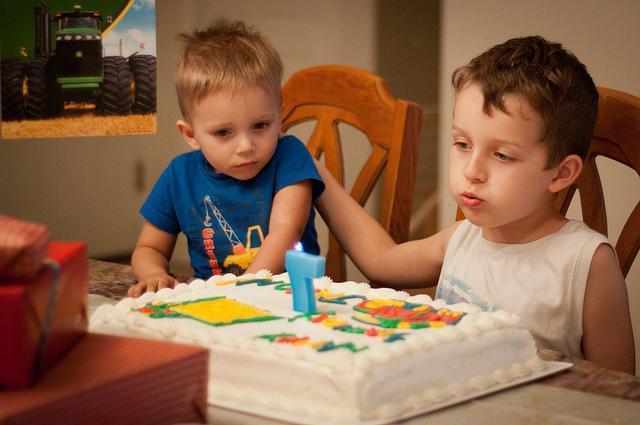Is "The cake is in front of the truck." an appropriate description for the image?
Answer yes or no. Yes. Is "The cake consists of the truck." an appropriate description for the image?
Answer yes or no. No. Is "The truck is in the cake." an appropriate description for the image?
Answer yes or no. No. Is the caption "The cake is part of the truck." a true representation of the image?
Answer yes or no. No. Is the given caption "The truck is part of the cake." fitting for the image?
Answer yes or no. No. 